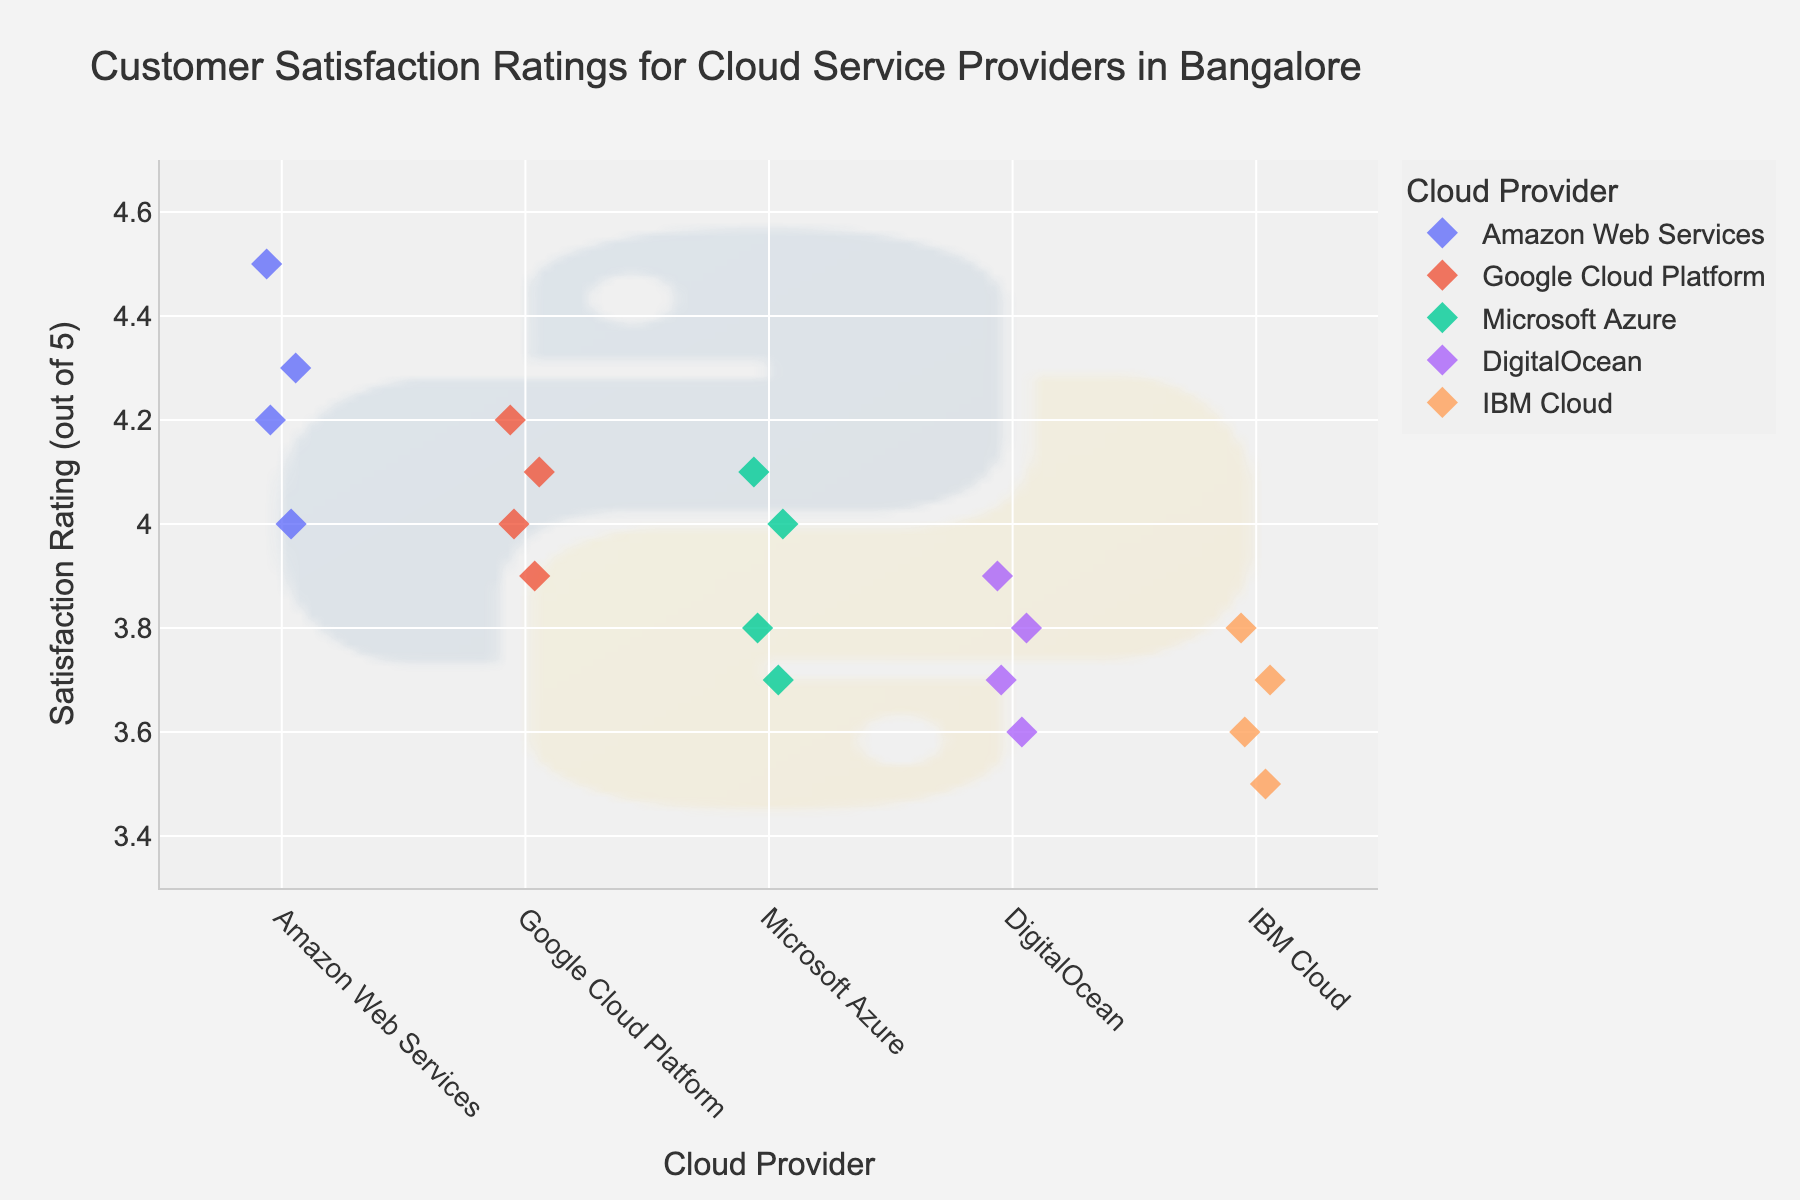What is the average satisfaction rating for Amazon Web Services? To determine the average satisfaction rating, sum up the ratings for Amazon Web Services (4.2 + 4.5 + 4.0 + 4.3) which results in 17.0, then divide by the number of ratings (4). Therefore, the average is 17.0 / 4 = 4.25.
Answer: 4.25 Which cloud service provider has the highest individual satisfaction rating? Identify the highest satisfaction rating for each provider and compare them. AWS has 4.5, GCP has 4.2, Microsoft Azure has 4.1, DigitalOcean has 3.9, and IBM Cloud has 3.8. AWS has the highest rating with 4.5.
Answer: Amazon Web Services How many data points are there for Google Cloud Platform? Count the number of data points specifically for Google Cloud Platform. In the data provided, there are four ratings listed for Google Cloud Platform.
Answer: 4 Which provider has the lowest average satisfaction rating? Calculate the average for each provider: AWS (4.25), GCP (4.05), Azure (3.9), DigitalOcean (3.75), IBM Cloud (3.65). Compare these averages; IBM Cloud has the lowest average.
Answer: IBM Cloud Do any cloud providers have the same number of satisfaction ratings? Count the ratings for each provider: AWS (4), GCP (4), Azure (4), DigitalOcean (4), IBM Cloud (4). All have the same number of ratings, which is 4.
Answer: Yes What is the range of satisfaction ratings for Microsoft Azure? Identify the minimum and maximum ratings for Microsoft Azure: minimum is 3.7, and maximum is 4.1. Subtract the minimum rating from the maximum rating: 4.1 - 3.7 = 0.4.
Answer: 0.4 Which cloud provider has the most variation in their ratings? Examine the spread of data points for each provider: AWS (4.0-4.5), GCP (3.9-4.2), Azure (3.7-4.1), DigitalOcean (3.6-3.9), IBM Cloud (3.5-3.8). IBM Cloud has the widest range (0.3).
Answer: IBM Cloud Are there any outliers in the satisfaction ratings for any of the cloud providers? Review the dispersion of the ratings visually. No satisfaction rating seems drastically different from the rest of any provider’s ratings. Thus, there are no significant outliers.
Answer: No Which cloud provider has the highest median satisfaction rating? Arrange ratings for each provider in ascending order: AWS (4.0, 4.2, 4.3, 4.5; median=4.25), GCP (3.9, 4.0, 4.1, 4.2; median=4.05), Azure (3.7, 3.8, 4.0, 4.1; median=3.9), DigitalOcean (3.6, 3.7, 3.8, 3.9; median=3.75), IBM Cloud (3.5, 3.6, 3.7, 3.8; median=3.65). AWS has the highest median rating.
Answer: Amazon Web Services 